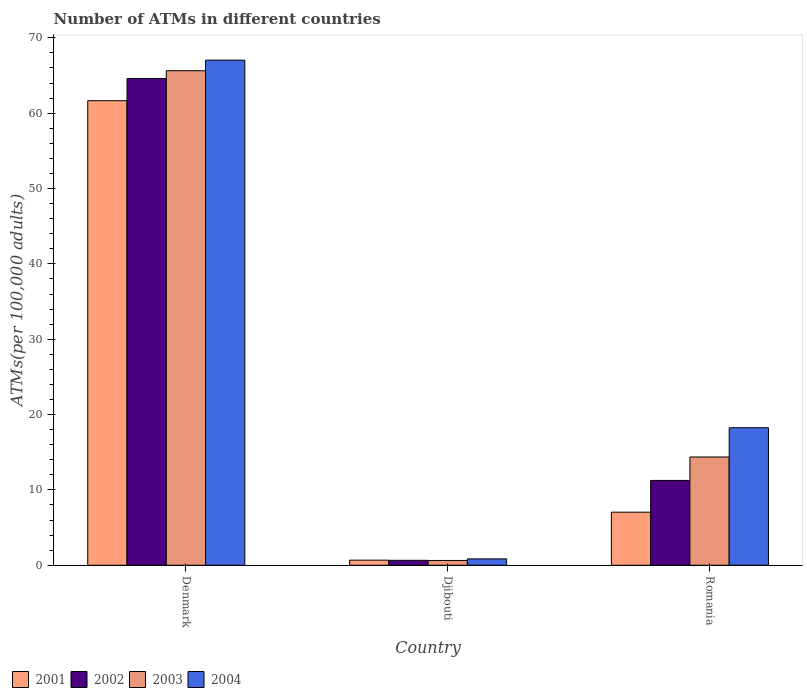How many groups of bars are there?
Give a very brief answer. 3. Are the number of bars per tick equal to the number of legend labels?
Offer a very short reply. Yes. How many bars are there on the 3rd tick from the left?
Give a very brief answer. 4. What is the label of the 2nd group of bars from the left?
Your answer should be compact. Djibouti. In how many cases, is the number of bars for a given country not equal to the number of legend labels?
Offer a very short reply. 0. What is the number of ATMs in 2001 in Djibouti?
Keep it short and to the point. 0.68. Across all countries, what is the maximum number of ATMs in 2002?
Your answer should be compact. 64.61. Across all countries, what is the minimum number of ATMs in 2002?
Provide a succinct answer. 0.66. In which country was the number of ATMs in 2001 minimum?
Your answer should be compact. Djibouti. What is the total number of ATMs in 2001 in the graph?
Your answer should be compact. 69.38. What is the difference between the number of ATMs in 2001 in Djibouti and that in Romania?
Offer a very short reply. -6.37. What is the difference between the number of ATMs in 2004 in Djibouti and the number of ATMs in 2002 in Romania?
Provide a succinct answer. -10.42. What is the average number of ATMs in 2002 per country?
Make the answer very short. 25.51. What is the difference between the number of ATMs of/in 2004 and number of ATMs of/in 2003 in Denmark?
Ensure brevity in your answer.  1.41. What is the ratio of the number of ATMs in 2002 in Denmark to that in Djibouti?
Keep it short and to the point. 98.45. What is the difference between the highest and the second highest number of ATMs in 2002?
Offer a very short reply. 63.95. What is the difference between the highest and the lowest number of ATMs in 2001?
Ensure brevity in your answer.  60.98. In how many countries, is the number of ATMs in 2004 greater than the average number of ATMs in 2004 taken over all countries?
Keep it short and to the point. 1. Is it the case that in every country, the sum of the number of ATMs in 2004 and number of ATMs in 2003 is greater than the sum of number of ATMs in 2002 and number of ATMs in 2001?
Offer a very short reply. No. Is it the case that in every country, the sum of the number of ATMs in 2002 and number of ATMs in 2001 is greater than the number of ATMs in 2004?
Your answer should be very brief. Yes. Are all the bars in the graph horizontal?
Ensure brevity in your answer.  No. Does the graph contain any zero values?
Your answer should be very brief. No. Does the graph contain grids?
Keep it short and to the point. No. Where does the legend appear in the graph?
Your response must be concise. Bottom left. How many legend labels are there?
Your answer should be compact. 4. How are the legend labels stacked?
Make the answer very short. Horizontal. What is the title of the graph?
Make the answer very short. Number of ATMs in different countries. What is the label or title of the X-axis?
Provide a succinct answer. Country. What is the label or title of the Y-axis?
Give a very brief answer. ATMs(per 100,0 adults). What is the ATMs(per 100,000 adults) in 2001 in Denmark?
Your answer should be very brief. 61.66. What is the ATMs(per 100,000 adults) of 2002 in Denmark?
Provide a short and direct response. 64.61. What is the ATMs(per 100,000 adults) in 2003 in Denmark?
Offer a terse response. 65.64. What is the ATMs(per 100,000 adults) in 2004 in Denmark?
Offer a very short reply. 67.04. What is the ATMs(per 100,000 adults) of 2001 in Djibouti?
Ensure brevity in your answer.  0.68. What is the ATMs(per 100,000 adults) of 2002 in Djibouti?
Provide a succinct answer. 0.66. What is the ATMs(per 100,000 adults) in 2003 in Djibouti?
Your answer should be very brief. 0.64. What is the ATMs(per 100,000 adults) in 2004 in Djibouti?
Give a very brief answer. 0.84. What is the ATMs(per 100,000 adults) of 2001 in Romania?
Keep it short and to the point. 7.04. What is the ATMs(per 100,000 adults) in 2002 in Romania?
Your answer should be very brief. 11.26. What is the ATMs(per 100,000 adults) in 2003 in Romania?
Give a very brief answer. 14.37. What is the ATMs(per 100,000 adults) in 2004 in Romania?
Your answer should be compact. 18.26. Across all countries, what is the maximum ATMs(per 100,000 adults) in 2001?
Give a very brief answer. 61.66. Across all countries, what is the maximum ATMs(per 100,000 adults) of 2002?
Your answer should be very brief. 64.61. Across all countries, what is the maximum ATMs(per 100,000 adults) in 2003?
Offer a terse response. 65.64. Across all countries, what is the maximum ATMs(per 100,000 adults) of 2004?
Offer a terse response. 67.04. Across all countries, what is the minimum ATMs(per 100,000 adults) in 2001?
Your answer should be compact. 0.68. Across all countries, what is the minimum ATMs(per 100,000 adults) of 2002?
Make the answer very short. 0.66. Across all countries, what is the minimum ATMs(per 100,000 adults) in 2003?
Make the answer very short. 0.64. Across all countries, what is the minimum ATMs(per 100,000 adults) in 2004?
Offer a terse response. 0.84. What is the total ATMs(per 100,000 adults) of 2001 in the graph?
Give a very brief answer. 69.38. What is the total ATMs(per 100,000 adults) of 2002 in the graph?
Give a very brief answer. 76.52. What is the total ATMs(per 100,000 adults) of 2003 in the graph?
Your response must be concise. 80.65. What is the total ATMs(per 100,000 adults) of 2004 in the graph?
Offer a terse response. 86.14. What is the difference between the ATMs(per 100,000 adults) in 2001 in Denmark and that in Djibouti?
Ensure brevity in your answer.  60.98. What is the difference between the ATMs(per 100,000 adults) of 2002 in Denmark and that in Djibouti?
Provide a short and direct response. 63.95. What is the difference between the ATMs(per 100,000 adults) in 2003 in Denmark and that in Djibouti?
Your answer should be compact. 65. What is the difference between the ATMs(per 100,000 adults) of 2004 in Denmark and that in Djibouti?
Your answer should be very brief. 66.2. What is the difference between the ATMs(per 100,000 adults) in 2001 in Denmark and that in Romania?
Provide a succinct answer. 54.61. What is the difference between the ATMs(per 100,000 adults) in 2002 in Denmark and that in Romania?
Provide a succinct answer. 53.35. What is the difference between the ATMs(per 100,000 adults) of 2003 in Denmark and that in Romania?
Your answer should be very brief. 51.27. What is the difference between the ATMs(per 100,000 adults) of 2004 in Denmark and that in Romania?
Give a very brief answer. 48.79. What is the difference between the ATMs(per 100,000 adults) of 2001 in Djibouti and that in Romania?
Offer a terse response. -6.37. What is the difference between the ATMs(per 100,000 adults) of 2002 in Djibouti and that in Romania?
Make the answer very short. -10.6. What is the difference between the ATMs(per 100,000 adults) of 2003 in Djibouti and that in Romania?
Ensure brevity in your answer.  -13.73. What is the difference between the ATMs(per 100,000 adults) of 2004 in Djibouti and that in Romania?
Provide a succinct answer. -17.41. What is the difference between the ATMs(per 100,000 adults) in 2001 in Denmark and the ATMs(per 100,000 adults) in 2002 in Djibouti?
Make the answer very short. 61. What is the difference between the ATMs(per 100,000 adults) of 2001 in Denmark and the ATMs(per 100,000 adults) of 2003 in Djibouti?
Your response must be concise. 61.02. What is the difference between the ATMs(per 100,000 adults) of 2001 in Denmark and the ATMs(per 100,000 adults) of 2004 in Djibouti?
Give a very brief answer. 60.81. What is the difference between the ATMs(per 100,000 adults) in 2002 in Denmark and the ATMs(per 100,000 adults) in 2003 in Djibouti?
Provide a succinct answer. 63.97. What is the difference between the ATMs(per 100,000 adults) in 2002 in Denmark and the ATMs(per 100,000 adults) in 2004 in Djibouti?
Provide a succinct answer. 63.76. What is the difference between the ATMs(per 100,000 adults) of 2003 in Denmark and the ATMs(per 100,000 adults) of 2004 in Djibouti?
Ensure brevity in your answer.  64.79. What is the difference between the ATMs(per 100,000 adults) in 2001 in Denmark and the ATMs(per 100,000 adults) in 2002 in Romania?
Your response must be concise. 50.4. What is the difference between the ATMs(per 100,000 adults) of 2001 in Denmark and the ATMs(per 100,000 adults) of 2003 in Romania?
Your response must be concise. 47.29. What is the difference between the ATMs(per 100,000 adults) in 2001 in Denmark and the ATMs(per 100,000 adults) in 2004 in Romania?
Your response must be concise. 43.4. What is the difference between the ATMs(per 100,000 adults) of 2002 in Denmark and the ATMs(per 100,000 adults) of 2003 in Romania?
Offer a terse response. 50.24. What is the difference between the ATMs(per 100,000 adults) in 2002 in Denmark and the ATMs(per 100,000 adults) in 2004 in Romania?
Keep it short and to the point. 46.35. What is the difference between the ATMs(per 100,000 adults) in 2003 in Denmark and the ATMs(per 100,000 adults) in 2004 in Romania?
Provide a short and direct response. 47.38. What is the difference between the ATMs(per 100,000 adults) of 2001 in Djibouti and the ATMs(per 100,000 adults) of 2002 in Romania?
Keep it short and to the point. -10.58. What is the difference between the ATMs(per 100,000 adults) of 2001 in Djibouti and the ATMs(per 100,000 adults) of 2003 in Romania?
Your answer should be compact. -13.69. What is the difference between the ATMs(per 100,000 adults) of 2001 in Djibouti and the ATMs(per 100,000 adults) of 2004 in Romania?
Give a very brief answer. -17.58. What is the difference between the ATMs(per 100,000 adults) in 2002 in Djibouti and the ATMs(per 100,000 adults) in 2003 in Romania?
Your answer should be compact. -13.71. What is the difference between the ATMs(per 100,000 adults) of 2002 in Djibouti and the ATMs(per 100,000 adults) of 2004 in Romania?
Your response must be concise. -17.6. What is the difference between the ATMs(per 100,000 adults) of 2003 in Djibouti and the ATMs(per 100,000 adults) of 2004 in Romania?
Keep it short and to the point. -17.62. What is the average ATMs(per 100,000 adults) in 2001 per country?
Keep it short and to the point. 23.13. What is the average ATMs(per 100,000 adults) of 2002 per country?
Make the answer very short. 25.51. What is the average ATMs(per 100,000 adults) in 2003 per country?
Make the answer very short. 26.88. What is the average ATMs(per 100,000 adults) of 2004 per country?
Your response must be concise. 28.71. What is the difference between the ATMs(per 100,000 adults) in 2001 and ATMs(per 100,000 adults) in 2002 in Denmark?
Make the answer very short. -2.95. What is the difference between the ATMs(per 100,000 adults) in 2001 and ATMs(per 100,000 adults) in 2003 in Denmark?
Offer a terse response. -3.98. What is the difference between the ATMs(per 100,000 adults) of 2001 and ATMs(per 100,000 adults) of 2004 in Denmark?
Your response must be concise. -5.39. What is the difference between the ATMs(per 100,000 adults) of 2002 and ATMs(per 100,000 adults) of 2003 in Denmark?
Ensure brevity in your answer.  -1.03. What is the difference between the ATMs(per 100,000 adults) of 2002 and ATMs(per 100,000 adults) of 2004 in Denmark?
Keep it short and to the point. -2.44. What is the difference between the ATMs(per 100,000 adults) of 2003 and ATMs(per 100,000 adults) of 2004 in Denmark?
Your response must be concise. -1.41. What is the difference between the ATMs(per 100,000 adults) of 2001 and ATMs(per 100,000 adults) of 2002 in Djibouti?
Provide a succinct answer. 0.02. What is the difference between the ATMs(per 100,000 adults) in 2001 and ATMs(per 100,000 adults) in 2003 in Djibouti?
Offer a very short reply. 0.04. What is the difference between the ATMs(per 100,000 adults) in 2001 and ATMs(per 100,000 adults) in 2004 in Djibouti?
Your answer should be very brief. -0.17. What is the difference between the ATMs(per 100,000 adults) of 2002 and ATMs(per 100,000 adults) of 2003 in Djibouti?
Offer a terse response. 0.02. What is the difference between the ATMs(per 100,000 adults) in 2002 and ATMs(per 100,000 adults) in 2004 in Djibouti?
Ensure brevity in your answer.  -0.19. What is the difference between the ATMs(per 100,000 adults) of 2003 and ATMs(per 100,000 adults) of 2004 in Djibouti?
Your response must be concise. -0.21. What is the difference between the ATMs(per 100,000 adults) of 2001 and ATMs(per 100,000 adults) of 2002 in Romania?
Provide a short and direct response. -4.21. What is the difference between the ATMs(per 100,000 adults) in 2001 and ATMs(per 100,000 adults) in 2003 in Romania?
Provide a succinct answer. -7.32. What is the difference between the ATMs(per 100,000 adults) in 2001 and ATMs(per 100,000 adults) in 2004 in Romania?
Provide a short and direct response. -11.21. What is the difference between the ATMs(per 100,000 adults) in 2002 and ATMs(per 100,000 adults) in 2003 in Romania?
Offer a terse response. -3.11. What is the difference between the ATMs(per 100,000 adults) in 2002 and ATMs(per 100,000 adults) in 2004 in Romania?
Offer a terse response. -7. What is the difference between the ATMs(per 100,000 adults) in 2003 and ATMs(per 100,000 adults) in 2004 in Romania?
Ensure brevity in your answer.  -3.89. What is the ratio of the ATMs(per 100,000 adults) in 2001 in Denmark to that in Djibouti?
Make the answer very short. 91.18. What is the ratio of the ATMs(per 100,000 adults) of 2002 in Denmark to that in Djibouti?
Offer a very short reply. 98.45. What is the ratio of the ATMs(per 100,000 adults) in 2003 in Denmark to that in Djibouti?
Make the answer very short. 102.88. What is the ratio of the ATMs(per 100,000 adults) of 2004 in Denmark to that in Djibouti?
Keep it short and to the point. 79.46. What is the ratio of the ATMs(per 100,000 adults) of 2001 in Denmark to that in Romania?
Your answer should be very brief. 8.75. What is the ratio of the ATMs(per 100,000 adults) of 2002 in Denmark to that in Romania?
Offer a very short reply. 5.74. What is the ratio of the ATMs(per 100,000 adults) in 2003 in Denmark to that in Romania?
Make the answer very short. 4.57. What is the ratio of the ATMs(per 100,000 adults) of 2004 in Denmark to that in Romania?
Offer a terse response. 3.67. What is the ratio of the ATMs(per 100,000 adults) in 2001 in Djibouti to that in Romania?
Provide a succinct answer. 0.1. What is the ratio of the ATMs(per 100,000 adults) of 2002 in Djibouti to that in Romania?
Your answer should be compact. 0.06. What is the ratio of the ATMs(per 100,000 adults) in 2003 in Djibouti to that in Romania?
Offer a terse response. 0.04. What is the ratio of the ATMs(per 100,000 adults) of 2004 in Djibouti to that in Romania?
Make the answer very short. 0.05. What is the difference between the highest and the second highest ATMs(per 100,000 adults) in 2001?
Keep it short and to the point. 54.61. What is the difference between the highest and the second highest ATMs(per 100,000 adults) in 2002?
Provide a short and direct response. 53.35. What is the difference between the highest and the second highest ATMs(per 100,000 adults) of 2003?
Offer a very short reply. 51.27. What is the difference between the highest and the second highest ATMs(per 100,000 adults) of 2004?
Your response must be concise. 48.79. What is the difference between the highest and the lowest ATMs(per 100,000 adults) in 2001?
Provide a short and direct response. 60.98. What is the difference between the highest and the lowest ATMs(per 100,000 adults) in 2002?
Give a very brief answer. 63.95. What is the difference between the highest and the lowest ATMs(per 100,000 adults) in 2003?
Offer a very short reply. 65. What is the difference between the highest and the lowest ATMs(per 100,000 adults) of 2004?
Your answer should be very brief. 66.2. 